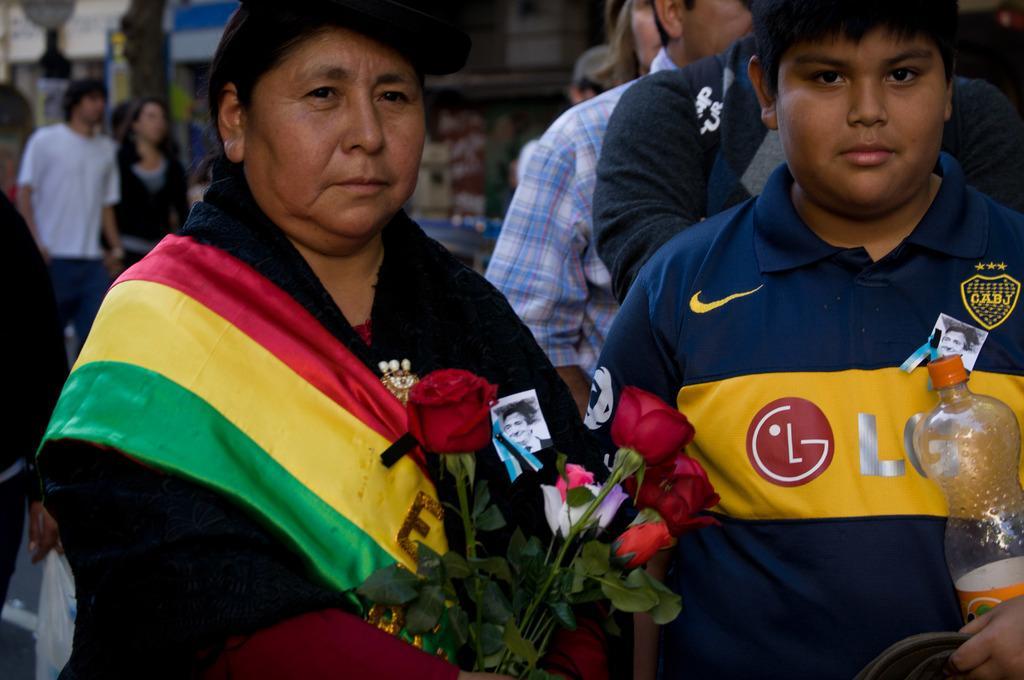Can you describe this image briefly? Here in the front we can see two people standing with roses in their hand and a bottle present, behind them also we can see group of people Walking Through The Road 